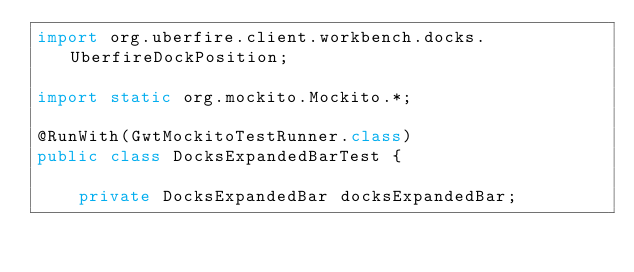<code> <loc_0><loc_0><loc_500><loc_500><_Java_>import org.uberfire.client.workbench.docks.UberfireDockPosition;

import static org.mockito.Mockito.*;

@RunWith(GwtMockitoTestRunner.class)
public class DocksExpandedBarTest {

    private DocksExpandedBar docksExpandedBar;
</code> 